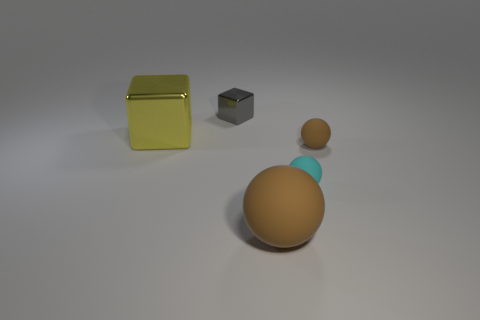Add 2 small metallic spheres. How many objects exist? 7 Subtract all balls. How many objects are left? 2 Add 5 small metal cylinders. How many small metal cylinders exist? 5 Subtract 1 cyan spheres. How many objects are left? 4 Subtract all gray shiny objects. Subtract all brown rubber objects. How many objects are left? 2 Add 4 cyan matte spheres. How many cyan matte spheres are left? 5 